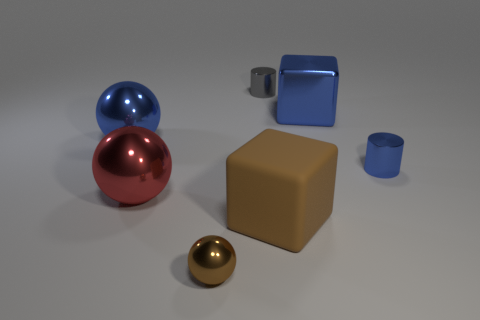Are there any other things that are made of the same material as the brown block? Yes, the brown block appears to be matte and plastic, as does the blue hollow cube and the cup in the background, which have a similar material finish. 